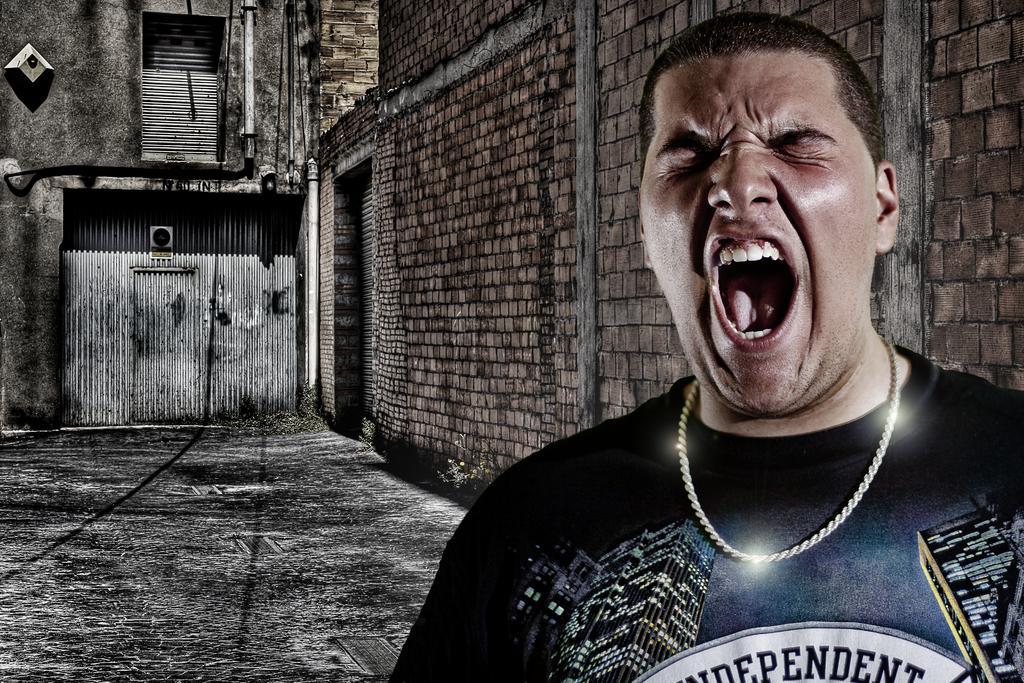In one or two sentences, can you explain what this image depicts? In this image we can see a shed, walls, pipelines and a man standing on the floor. 